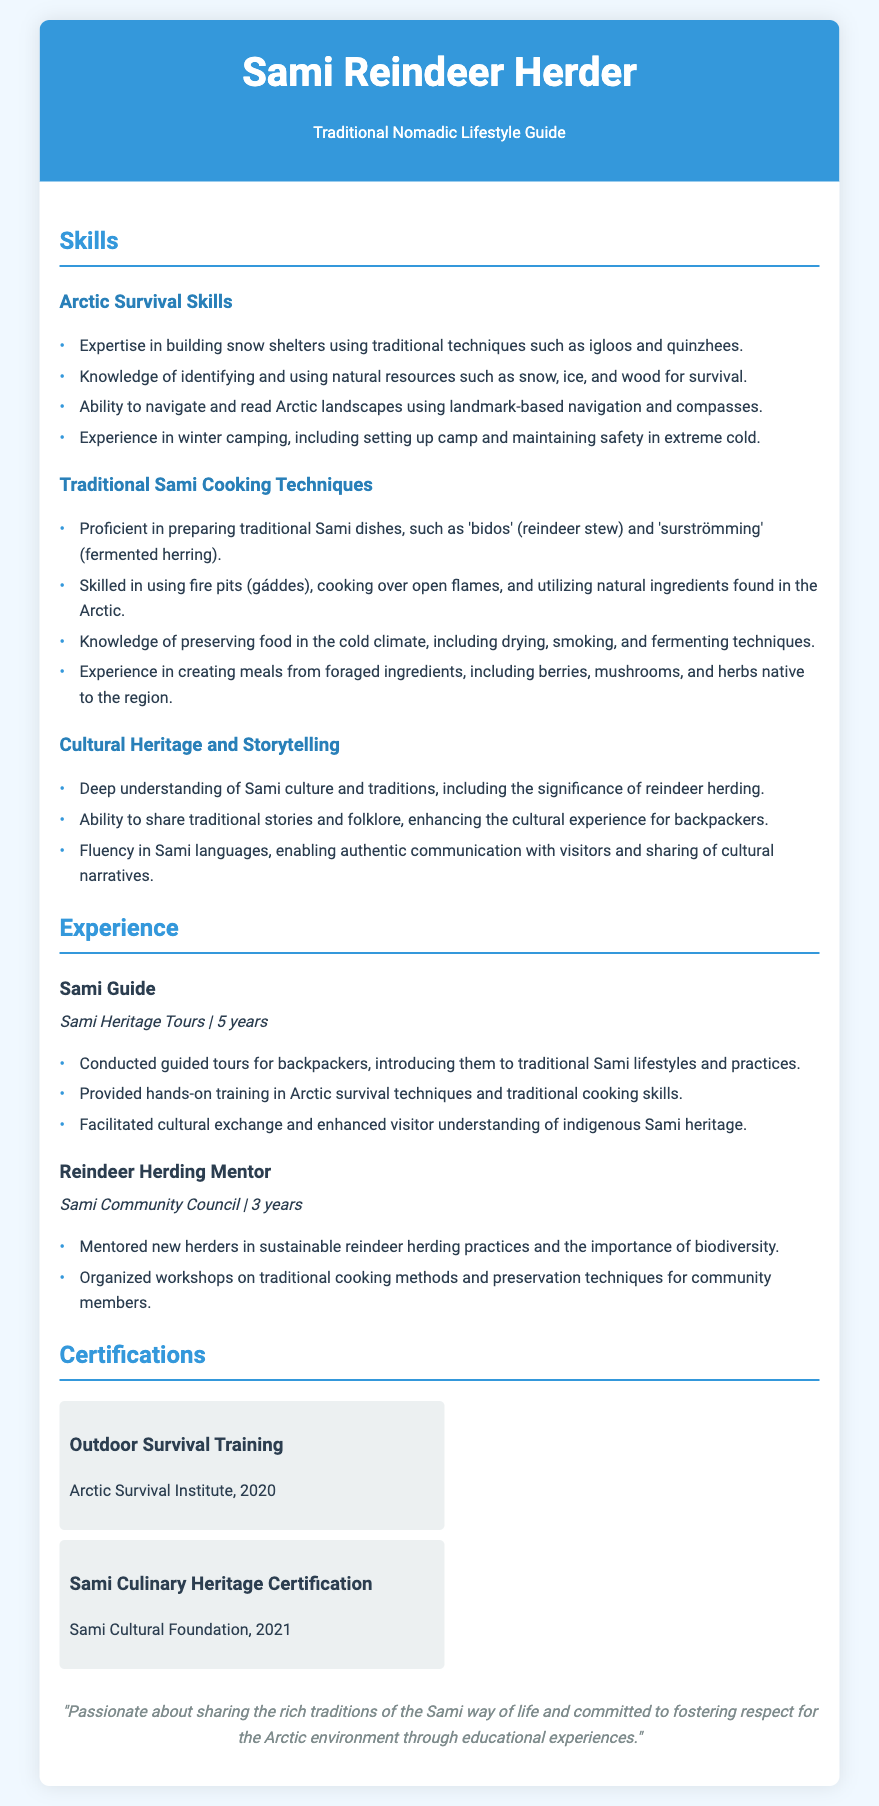What are the names of the two main skill areas listed? The two main skill areas listed are Arctic Survival Skills and Traditional Sami Cooking Techniques.
Answer: Arctic Survival Skills, Traditional Sami Cooking Techniques How many years of experience does the Sami Guide position have? The Sami Guide position has 5 years of experience, as stated in the document.
Answer: 5 years What is one traditional dish the guide is proficient in preparing? The guide is proficient in preparing 'bidos' (reindeer stew), which is specifically mentioned in the document.
Answer: bidos Which organization provided the Outdoor Survival Training certification? The document states that the certification was provided by the Arctic Survival Institute.
Answer: Arctic Survival Institute What essential cultural aspect does the guide share with backpackers? The guide enhances the cultural experience for backpackers by sharing traditional stories and folklore.
Answer: traditional stories and folklore How many certifications are listed in the document? The document lists two certifications: Outdoor Survival Training and Sami Culinary Heritage Certification.
Answer: 2 What is the main focus of the personal statement? The personal statement focuses on the passion for sharing Sami traditions and respecting the Arctic environment.
Answer: sharing the rich traditions of the Sami way of life What natural skills does the guide teach visitors during tours? The guide teaches hands-on training in Arctic survival techniques and traditional cooking skills during the tours.
Answer: Arctic survival techniques, traditional cooking skills How long did the guide work as a Reindeer Herding Mentor? The guide worked as a Reindeer Herding Mentor for 3 years, as detailed in the experience section.
Answer: 3 years 